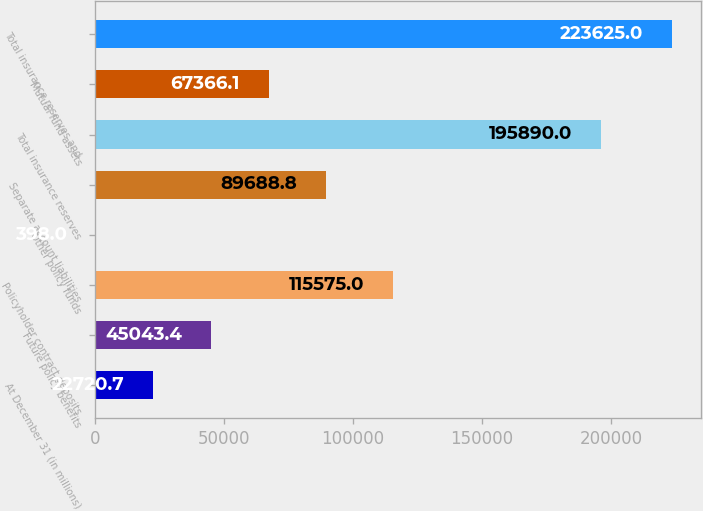Convert chart. <chart><loc_0><loc_0><loc_500><loc_500><bar_chart><fcel>At December 31 (in millions)<fcel>Future policy benefits<fcel>Policyholder contract deposits<fcel>Other policy funds<fcel>Separate account liabilities<fcel>Total insurance reserves<fcel>Mutual fund assets<fcel>Total insurance reserves and<nl><fcel>22720.7<fcel>45043.4<fcel>115575<fcel>398<fcel>89688.8<fcel>195890<fcel>67366.1<fcel>223625<nl></chart> 